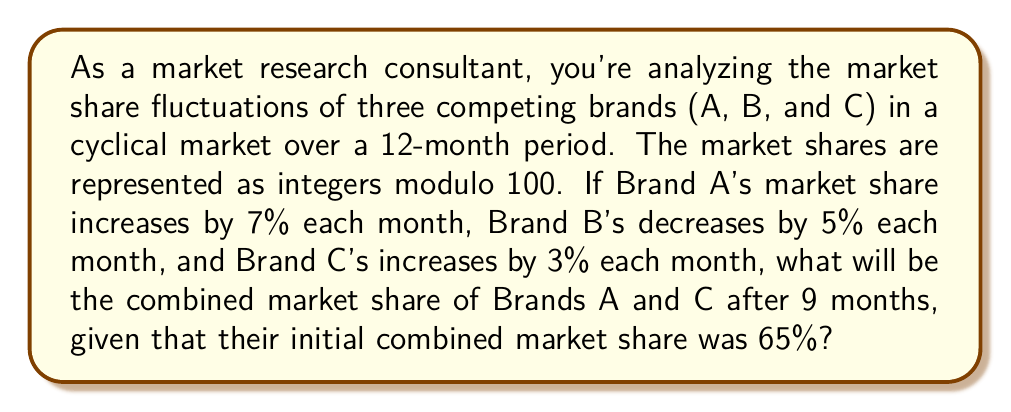Help me with this question. Let's approach this step-by-step using modular arithmetic:

1) Initial combined market share of A and C: 65%

2) Monthly changes:
   Brand A: +7% per month
   Brand C: +3% per month
   Combined change: +10% per month

3) We need to calculate the effect of a 10% increase each month for 9 months.

4) In modular arithmetic (mod 100), this is equivalent to:

   $$(65 + 10 \cdot 9) \bmod 100$$

5) Let's break this down:
   $$65 + (10 \cdot 9) = 65 + 90 = 155$$

6) Now, we need to find 155 mod 100:
   $$155 \bmod 100 = 55$$

7) Therefore, after 9 months, the combined market share of Brands A and C will be 55%.

Note: This approach using modular arithmetic automatically accounts for the cyclical nature of market shares, where percentages wrap around when they exceed 100%.
Answer: 55% 